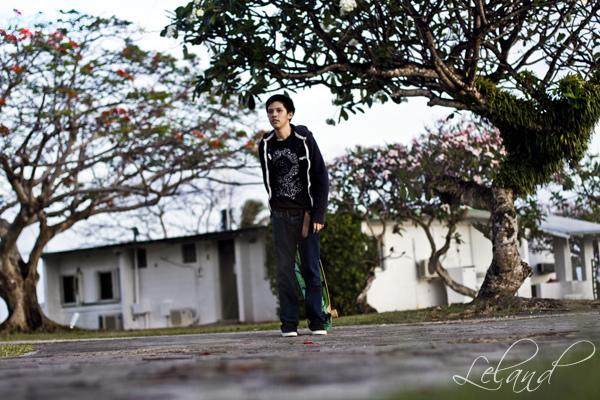What color is his shirt?
Write a very short answer. Black. Is there a big building in the background?
Keep it brief. Yes. How many windows?
Give a very brief answer. 4. 